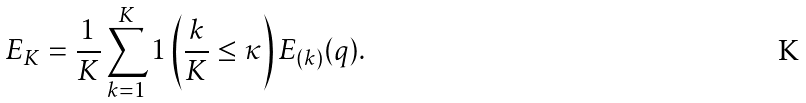Convert formula to latex. <formula><loc_0><loc_0><loc_500><loc_500>E _ { K } = \frac { 1 } { K } \sum _ { k = 1 } ^ { K } 1 \left ( \frac { k } { K } \leq \kappa \right ) E _ { ( k ) } ( q ) .</formula> 